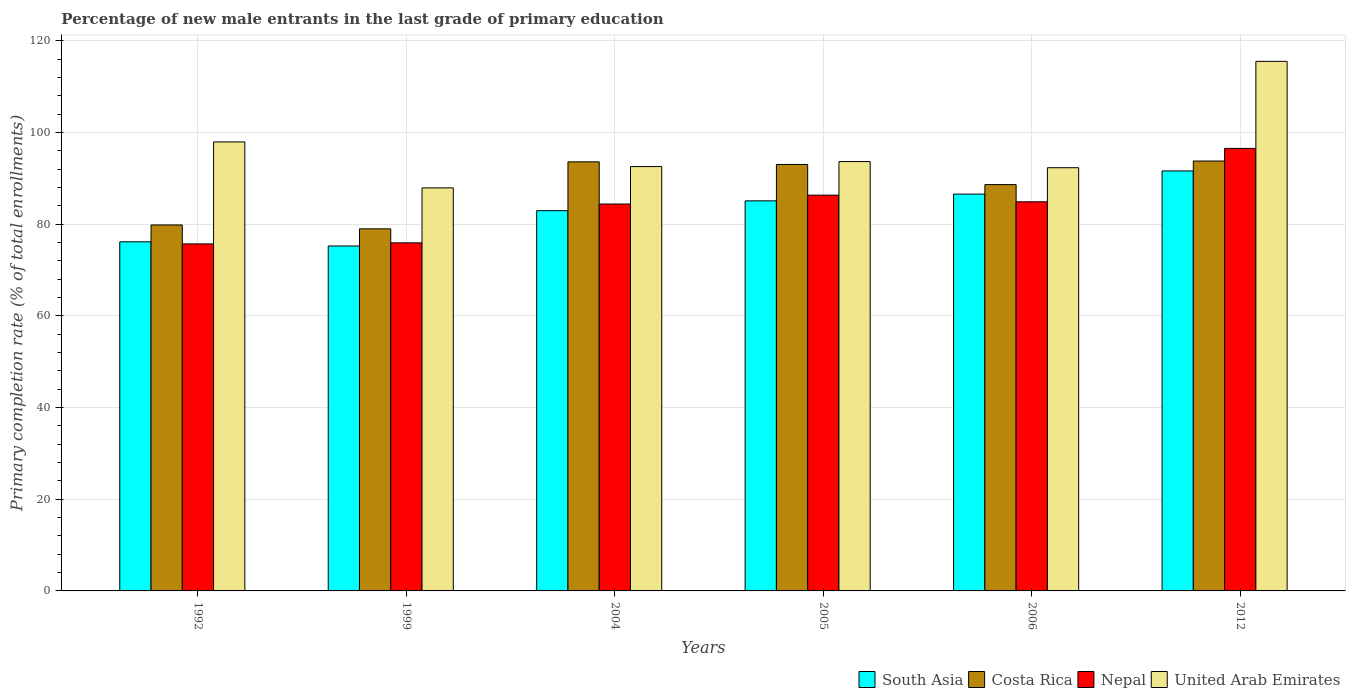How many different coloured bars are there?
Offer a very short reply. 4. How many groups of bars are there?
Provide a succinct answer. 6. What is the label of the 5th group of bars from the left?
Your response must be concise. 2006. What is the percentage of new male entrants in United Arab Emirates in 2004?
Your answer should be very brief. 92.6. Across all years, what is the maximum percentage of new male entrants in South Asia?
Offer a very short reply. 91.64. Across all years, what is the minimum percentage of new male entrants in South Asia?
Your response must be concise. 75.27. In which year was the percentage of new male entrants in South Asia minimum?
Ensure brevity in your answer.  1999. What is the total percentage of new male entrants in Nepal in the graph?
Your response must be concise. 503.93. What is the difference between the percentage of new male entrants in Nepal in 1999 and that in 2004?
Ensure brevity in your answer.  -8.47. What is the difference between the percentage of new male entrants in United Arab Emirates in 2006 and the percentage of new male entrants in South Asia in 1999?
Give a very brief answer. 17.08. What is the average percentage of new male entrants in Costa Rica per year?
Your answer should be very brief. 88. In the year 2004, what is the difference between the percentage of new male entrants in United Arab Emirates and percentage of new male entrants in Costa Rica?
Offer a very short reply. -1.03. In how many years, is the percentage of new male entrants in United Arab Emirates greater than 40 %?
Provide a succinct answer. 6. What is the ratio of the percentage of new male entrants in Costa Rica in 1992 to that in 1999?
Your answer should be very brief. 1.01. Is the percentage of new male entrants in Costa Rica in 1992 less than that in 2006?
Your response must be concise. Yes. What is the difference between the highest and the second highest percentage of new male entrants in Costa Rica?
Offer a very short reply. 0.17. What is the difference between the highest and the lowest percentage of new male entrants in South Asia?
Ensure brevity in your answer.  16.38. Is it the case that in every year, the sum of the percentage of new male entrants in Nepal and percentage of new male entrants in Costa Rica is greater than the sum of percentage of new male entrants in South Asia and percentage of new male entrants in United Arab Emirates?
Make the answer very short. No. What does the 1st bar from the left in 2012 represents?
Ensure brevity in your answer.  South Asia. Is it the case that in every year, the sum of the percentage of new male entrants in United Arab Emirates and percentage of new male entrants in Nepal is greater than the percentage of new male entrants in South Asia?
Give a very brief answer. Yes. How many bars are there?
Your answer should be very brief. 24. Are all the bars in the graph horizontal?
Your response must be concise. No. How many years are there in the graph?
Provide a short and direct response. 6. Does the graph contain grids?
Provide a succinct answer. Yes. How are the legend labels stacked?
Your response must be concise. Horizontal. What is the title of the graph?
Your answer should be compact. Percentage of new male entrants in the last grade of primary education. Does "Greece" appear as one of the legend labels in the graph?
Your answer should be compact. No. What is the label or title of the X-axis?
Provide a succinct answer. Years. What is the label or title of the Y-axis?
Offer a very short reply. Primary completion rate (% of total enrollments). What is the Primary completion rate (% of total enrollments) of South Asia in 1992?
Make the answer very short. 76.18. What is the Primary completion rate (% of total enrollments) of Costa Rica in 1992?
Keep it short and to the point. 79.86. What is the Primary completion rate (% of total enrollments) of Nepal in 1992?
Your answer should be compact. 75.72. What is the Primary completion rate (% of total enrollments) in United Arab Emirates in 1992?
Ensure brevity in your answer.  97.98. What is the Primary completion rate (% of total enrollments) in South Asia in 1999?
Offer a very short reply. 75.27. What is the Primary completion rate (% of total enrollments) of Costa Rica in 1999?
Provide a short and direct response. 79.01. What is the Primary completion rate (% of total enrollments) of Nepal in 1999?
Provide a succinct answer. 75.95. What is the Primary completion rate (% of total enrollments) of United Arab Emirates in 1999?
Your answer should be very brief. 87.95. What is the Primary completion rate (% of total enrollments) of South Asia in 2004?
Your response must be concise. 82.98. What is the Primary completion rate (% of total enrollments) in Costa Rica in 2004?
Provide a succinct answer. 93.63. What is the Primary completion rate (% of total enrollments) of Nepal in 2004?
Provide a succinct answer. 84.42. What is the Primary completion rate (% of total enrollments) in United Arab Emirates in 2004?
Ensure brevity in your answer.  92.6. What is the Primary completion rate (% of total enrollments) in South Asia in 2005?
Keep it short and to the point. 85.12. What is the Primary completion rate (% of total enrollments) in Costa Rica in 2005?
Your answer should be compact. 93.06. What is the Primary completion rate (% of total enrollments) of Nepal in 2005?
Your answer should be compact. 86.36. What is the Primary completion rate (% of total enrollments) in United Arab Emirates in 2005?
Offer a very short reply. 93.69. What is the Primary completion rate (% of total enrollments) of South Asia in 2006?
Offer a very short reply. 86.59. What is the Primary completion rate (% of total enrollments) in Costa Rica in 2006?
Provide a short and direct response. 88.66. What is the Primary completion rate (% of total enrollments) in Nepal in 2006?
Keep it short and to the point. 84.91. What is the Primary completion rate (% of total enrollments) of United Arab Emirates in 2006?
Offer a very short reply. 92.35. What is the Primary completion rate (% of total enrollments) in South Asia in 2012?
Offer a terse response. 91.64. What is the Primary completion rate (% of total enrollments) in Costa Rica in 2012?
Give a very brief answer. 93.8. What is the Primary completion rate (% of total enrollments) in Nepal in 2012?
Provide a short and direct response. 96.56. What is the Primary completion rate (% of total enrollments) of United Arab Emirates in 2012?
Provide a succinct answer. 115.56. Across all years, what is the maximum Primary completion rate (% of total enrollments) in South Asia?
Make the answer very short. 91.64. Across all years, what is the maximum Primary completion rate (% of total enrollments) in Costa Rica?
Offer a terse response. 93.8. Across all years, what is the maximum Primary completion rate (% of total enrollments) of Nepal?
Offer a very short reply. 96.56. Across all years, what is the maximum Primary completion rate (% of total enrollments) in United Arab Emirates?
Ensure brevity in your answer.  115.56. Across all years, what is the minimum Primary completion rate (% of total enrollments) in South Asia?
Offer a very short reply. 75.27. Across all years, what is the minimum Primary completion rate (% of total enrollments) in Costa Rica?
Your answer should be very brief. 79.01. Across all years, what is the minimum Primary completion rate (% of total enrollments) of Nepal?
Your response must be concise. 75.72. Across all years, what is the minimum Primary completion rate (% of total enrollments) of United Arab Emirates?
Offer a very short reply. 87.95. What is the total Primary completion rate (% of total enrollments) in South Asia in the graph?
Offer a terse response. 497.77. What is the total Primary completion rate (% of total enrollments) of Costa Rica in the graph?
Offer a very short reply. 528.02. What is the total Primary completion rate (% of total enrollments) of Nepal in the graph?
Ensure brevity in your answer.  503.93. What is the total Primary completion rate (% of total enrollments) of United Arab Emirates in the graph?
Provide a succinct answer. 580.12. What is the difference between the Primary completion rate (% of total enrollments) in South Asia in 1992 and that in 1999?
Ensure brevity in your answer.  0.91. What is the difference between the Primary completion rate (% of total enrollments) in Costa Rica in 1992 and that in 1999?
Provide a short and direct response. 0.85. What is the difference between the Primary completion rate (% of total enrollments) of Nepal in 1992 and that in 1999?
Keep it short and to the point. -0.23. What is the difference between the Primary completion rate (% of total enrollments) in United Arab Emirates in 1992 and that in 1999?
Provide a succinct answer. 10.03. What is the difference between the Primary completion rate (% of total enrollments) in South Asia in 1992 and that in 2004?
Ensure brevity in your answer.  -6.8. What is the difference between the Primary completion rate (% of total enrollments) of Costa Rica in 1992 and that in 2004?
Keep it short and to the point. -13.77. What is the difference between the Primary completion rate (% of total enrollments) of Nepal in 1992 and that in 2004?
Give a very brief answer. -8.7. What is the difference between the Primary completion rate (% of total enrollments) in United Arab Emirates in 1992 and that in 2004?
Provide a succinct answer. 5.38. What is the difference between the Primary completion rate (% of total enrollments) in South Asia in 1992 and that in 2005?
Your answer should be very brief. -8.94. What is the difference between the Primary completion rate (% of total enrollments) in Costa Rica in 1992 and that in 2005?
Your answer should be very brief. -13.2. What is the difference between the Primary completion rate (% of total enrollments) in Nepal in 1992 and that in 2005?
Provide a short and direct response. -10.64. What is the difference between the Primary completion rate (% of total enrollments) in United Arab Emirates in 1992 and that in 2005?
Ensure brevity in your answer.  4.28. What is the difference between the Primary completion rate (% of total enrollments) of South Asia in 1992 and that in 2006?
Offer a very short reply. -10.41. What is the difference between the Primary completion rate (% of total enrollments) in Costa Rica in 1992 and that in 2006?
Make the answer very short. -8.81. What is the difference between the Primary completion rate (% of total enrollments) in Nepal in 1992 and that in 2006?
Offer a terse response. -9.19. What is the difference between the Primary completion rate (% of total enrollments) in United Arab Emirates in 1992 and that in 2006?
Keep it short and to the point. 5.63. What is the difference between the Primary completion rate (% of total enrollments) in South Asia in 1992 and that in 2012?
Provide a succinct answer. -15.46. What is the difference between the Primary completion rate (% of total enrollments) in Costa Rica in 1992 and that in 2012?
Provide a succinct answer. -13.95. What is the difference between the Primary completion rate (% of total enrollments) of Nepal in 1992 and that in 2012?
Offer a terse response. -20.84. What is the difference between the Primary completion rate (% of total enrollments) in United Arab Emirates in 1992 and that in 2012?
Make the answer very short. -17.58. What is the difference between the Primary completion rate (% of total enrollments) of South Asia in 1999 and that in 2004?
Keep it short and to the point. -7.71. What is the difference between the Primary completion rate (% of total enrollments) of Costa Rica in 1999 and that in 2004?
Offer a terse response. -14.62. What is the difference between the Primary completion rate (% of total enrollments) of Nepal in 1999 and that in 2004?
Your response must be concise. -8.47. What is the difference between the Primary completion rate (% of total enrollments) of United Arab Emirates in 1999 and that in 2004?
Offer a terse response. -4.65. What is the difference between the Primary completion rate (% of total enrollments) in South Asia in 1999 and that in 2005?
Your answer should be compact. -9.85. What is the difference between the Primary completion rate (% of total enrollments) in Costa Rica in 1999 and that in 2005?
Give a very brief answer. -14.05. What is the difference between the Primary completion rate (% of total enrollments) in Nepal in 1999 and that in 2005?
Offer a terse response. -10.41. What is the difference between the Primary completion rate (% of total enrollments) in United Arab Emirates in 1999 and that in 2005?
Give a very brief answer. -5.74. What is the difference between the Primary completion rate (% of total enrollments) in South Asia in 1999 and that in 2006?
Give a very brief answer. -11.32. What is the difference between the Primary completion rate (% of total enrollments) of Costa Rica in 1999 and that in 2006?
Your answer should be compact. -9.65. What is the difference between the Primary completion rate (% of total enrollments) of Nepal in 1999 and that in 2006?
Your response must be concise. -8.96. What is the difference between the Primary completion rate (% of total enrollments) of United Arab Emirates in 1999 and that in 2006?
Your answer should be very brief. -4.4. What is the difference between the Primary completion rate (% of total enrollments) in South Asia in 1999 and that in 2012?
Your response must be concise. -16.38. What is the difference between the Primary completion rate (% of total enrollments) in Costa Rica in 1999 and that in 2012?
Your response must be concise. -14.79. What is the difference between the Primary completion rate (% of total enrollments) in Nepal in 1999 and that in 2012?
Ensure brevity in your answer.  -20.61. What is the difference between the Primary completion rate (% of total enrollments) in United Arab Emirates in 1999 and that in 2012?
Keep it short and to the point. -27.61. What is the difference between the Primary completion rate (% of total enrollments) of South Asia in 2004 and that in 2005?
Ensure brevity in your answer.  -2.14. What is the difference between the Primary completion rate (% of total enrollments) of Costa Rica in 2004 and that in 2005?
Offer a very short reply. 0.57. What is the difference between the Primary completion rate (% of total enrollments) of Nepal in 2004 and that in 2005?
Offer a very short reply. -1.94. What is the difference between the Primary completion rate (% of total enrollments) in United Arab Emirates in 2004 and that in 2005?
Your answer should be compact. -1.1. What is the difference between the Primary completion rate (% of total enrollments) in South Asia in 2004 and that in 2006?
Ensure brevity in your answer.  -3.61. What is the difference between the Primary completion rate (% of total enrollments) in Costa Rica in 2004 and that in 2006?
Provide a short and direct response. 4.97. What is the difference between the Primary completion rate (% of total enrollments) of Nepal in 2004 and that in 2006?
Provide a succinct answer. -0.49. What is the difference between the Primary completion rate (% of total enrollments) of United Arab Emirates in 2004 and that in 2006?
Your answer should be compact. 0.25. What is the difference between the Primary completion rate (% of total enrollments) of South Asia in 2004 and that in 2012?
Provide a succinct answer. -8.67. What is the difference between the Primary completion rate (% of total enrollments) in Costa Rica in 2004 and that in 2012?
Provide a succinct answer. -0.17. What is the difference between the Primary completion rate (% of total enrollments) in Nepal in 2004 and that in 2012?
Provide a succinct answer. -12.14. What is the difference between the Primary completion rate (% of total enrollments) of United Arab Emirates in 2004 and that in 2012?
Your answer should be compact. -22.96. What is the difference between the Primary completion rate (% of total enrollments) of South Asia in 2005 and that in 2006?
Give a very brief answer. -1.47. What is the difference between the Primary completion rate (% of total enrollments) of Costa Rica in 2005 and that in 2006?
Your response must be concise. 4.39. What is the difference between the Primary completion rate (% of total enrollments) in Nepal in 2005 and that in 2006?
Your answer should be very brief. 1.45. What is the difference between the Primary completion rate (% of total enrollments) in United Arab Emirates in 2005 and that in 2006?
Make the answer very short. 1.34. What is the difference between the Primary completion rate (% of total enrollments) in South Asia in 2005 and that in 2012?
Keep it short and to the point. -6.53. What is the difference between the Primary completion rate (% of total enrollments) of Costa Rica in 2005 and that in 2012?
Ensure brevity in your answer.  -0.75. What is the difference between the Primary completion rate (% of total enrollments) in Nepal in 2005 and that in 2012?
Provide a succinct answer. -10.2. What is the difference between the Primary completion rate (% of total enrollments) of United Arab Emirates in 2005 and that in 2012?
Offer a terse response. -21.87. What is the difference between the Primary completion rate (% of total enrollments) in South Asia in 2006 and that in 2012?
Ensure brevity in your answer.  -5.05. What is the difference between the Primary completion rate (% of total enrollments) of Costa Rica in 2006 and that in 2012?
Provide a succinct answer. -5.14. What is the difference between the Primary completion rate (% of total enrollments) in Nepal in 2006 and that in 2012?
Offer a very short reply. -11.65. What is the difference between the Primary completion rate (% of total enrollments) in United Arab Emirates in 2006 and that in 2012?
Your response must be concise. -23.21. What is the difference between the Primary completion rate (% of total enrollments) in South Asia in 1992 and the Primary completion rate (% of total enrollments) in Costa Rica in 1999?
Offer a terse response. -2.83. What is the difference between the Primary completion rate (% of total enrollments) in South Asia in 1992 and the Primary completion rate (% of total enrollments) in Nepal in 1999?
Provide a succinct answer. 0.23. What is the difference between the Primary completion rate (% of total enrollments) in South Asia in 1992 and the Primary completion rate (% of total enrollments) in United Arab Emirates in 1999?
Give a very brief answer. -11.77. What is the difference between the Primary completion rate (% of total enrollments) in Costa Rica in 1992 and the Primary completion rate (% of total enrollments) in Nepal in 1999?
Offer a terse response. 3.91. What is the difference between the Primary completion rate (% of total enrollments) of Costa Rica in 1992 and the Primary completion rate (% of total enrollments) of United Arab Emirates in 1999?
Keep it short and to the point. -8.09. What is the difference between the Primary completion rate (% of total enrollments) in Nepal in 1992 and the Primary completion rate (% of total enrollments) in United Arab Emirates in 1999?
Your response must be concise. -12.23. What is the difference between the Primary completion rate (% of total enrollments) of South Asia in 1992 and the Primary completion rate (% of total enrollments) of Costa Rica in 2004?
Provide a short and direct response. -17.45. What is the difference between the Primary completion rate (% of total enrollments) of South Asia in 1992 and the Primary completion rate (% of total enrollments) of Nepal in 2004?
Provide a short and direct response. -8.24. What is the difference between the Primary completion rate (% of total enrollments) in South Asia in 1992 and the Primary completion rate (% of total enrollments) in United Arab Emirates in 2004?
Offer a very short reply. -16.42. What is the difference between the Primary completion rate (% of total enrollments) of Costa Rica in 1992 and the Primary completion rate (% of total enrollments) of Nepal in 2004?
Provide a succinct answer. -4.57. What is the difference between the Primary completion rate (% of total enrollments) of Costa Rica in 1992 and the Primary completion rate (% of total enrollments) of United Arab Emirates in 2004?
Provide a short and direct response. -12.74. What is the difference between the Primary completion rate (% of total enrollments) of Nepal in 1992 and the Primary completion rate (% of total enrollments) of United Arab Emirates in 2004?
Offer a terse response. -16.88. What is the difference between the Primary completion rate (% of total enrollments) of South Asia in 1992 and the Primary completion rate (% of total enrollments) of Costa Rica in 2005?
Ensure brevity in your answer.  -16.88. What is the difference between the Primary completion rate (% of total enrollments) in South Asia in 1992 and the Primary completion rate (% of total enrollments) in Nepal in 2005?
Give a very brief answer. -10.18. What is the difference between the Primary completion rate (% of total enrollments) of South Asia in 1992 and the Primary completion rate (% of total enrollments) of United Arab Emirates in 2005?
Your answer should be very brief. -17.51. What is the difference between the Primary completion rate (% of total enrollments) of Costa Rica in 1992 and the Primary completion rate (% of total enrollments) of Nepal in 2005?
Your response must be concise. -6.51. What is the difference between the Primary completion rate (% of total enrollments) of Costa Rica in 1992 and the Primary completion rate (% of total enrollments) of United Arab Emirates in 2005?
Ensure brevity in your answer.  -13.83. What is the difference between the Primary completion rate (% of total enrollments) of Nepal in 1992 and the Primary completion rate (% of total enrollments) of United Arab Emirates in 2005?
Give a very brief answer. -17.97. What is the difference between the Primary completion rate (% of total enrollments) in South Asia in 1992 and the Primary completion rate (% of total enrollments) in Costa Rica in 2006?
Offer a terse response. -12.48. What is the difference between the Primary completion rate (% of total enrollments) of South Asia in 1992 and the Primary completion rate (% of total enrollments) of Nepal in 2006?
Your answer should be very brief. -8.73. What is the difference between the Primary completion rate (% of total enrollments) of South Asia in 1992 and the Primary completion rate (% of total enrollments) of United Arab Emirates in 2006?
Ensure brevity in your answer.  -16.17. What is the difference between the Primary completion rate (% of total enrollments) in Costa Rica in 1992 and the Primary completion rate (% of total enrollments) in Nepal in 2006?
Make the answer very short. -5.06. What is the difference between the Primary completion rate (% of total enrollments) in Costa Rica in 1992 and the Primary completion rate (% of total enrollments) in United Arab Emirates in 2006?
Ensure brevity in your answer.  -12.49. What is the difference between the Primary completion rate (% of total enrollments) of Nepal in 1992 and the Primary completion rate (% of total enrollments) of United Arab Emirates in 2006?
Keep it short and to the point. -16.63. What is the difference between the Primary completion rate (% of total enrollments) in South Asia in 1992 and the Primary completion rate (% of total enrollments) in Costa Rica in 2012?
Provide a succinct answer. -17.62. What is the difference between the Primary completion rate (% of total enrollments) in South Asia in 1992 and the Primary completion rate (% of total enrollments) in Nepal in 2012?
Your response must be concise. -20.38. What is the difference between the Primary completion rate (% of total enrollments) in South Asia in 1992 and the Primary completion rate (% of total enrollments) in United Arab Emirates in 2012?
Offer a very short reply. -39.38. What is the difference between the Primary completion rate (% of total enrollments) in Costa Rica in 1992 and the Primary completion rate (% of total enrollments) in Nepal in 2012?
Offer a very short reply. -16.71. What is the difference between the Primary completion rate (% of total enrollments) in Costa Rica in 1992 and the Primary completion rate (% of total enrollments) in United Arab Emirates in 2012?
Your answer should be very brief. -35.7. What is the difference between the Primary completion rate (% of total enrollments) of Nepal in 1992 and the Primary completion rate (% of total enrollments) of United Arab Emirates in 2012?
Provide a short and direct response. -39.84. What is the difference between the Primary completion rate (% of total enrollments) in South Asia in 1999 and the Primary completion rate (% of total enrollments) in Costa Rica in 2004?
Your answer should be very brief. -18.36. What is the difference between the Primary completion rate (% of total enrollments) in South Asia in 1999 and the Primary completion rate (% of total enrollments) in Nepal in 2004?
Your answer should be compact. -9.16. What is the difference between the Primary completion rate (% of total enrollments) of South Asia in 1999 and the Primary completion rate (% of total enrollments) of United Arab Emirates in 2004?
Your answer should be compact. -17.33. What is the difference between the Primary completion rate (% of total enrollments) of Costa Rica in 1999 and the Primary completion rate (% of total enrollments) of Nepal in 2004?
Your answer should be compact. -5.41. What is the difference between the Primary completion rate (% of total enrollments) in Costa Rica in 1999 and the Primary completion rate (% of total enrollments) in United Arab Emirates in 2004?
Provide a short and direct response. -13.59. What is the difference between the Primary completion rate (% of total enrollments) in Nepal in 1999 and the Primary completion rate (% of total enrollments) in United Arab Emirates in 2004?
Offer a terse response. -16.65. What is the difference between the Primary completion rate (% of total enrollments) in South Asia in 1999 and the Primary completion rate (% of total enrollments) in Costa Rica in 2005?
Your response must be concise. -17.79. What is the difference between the Primary completion rate (% of total enrollments) of South Asia in 1999 and the Primary completion rate (% of total enrollments) of Nepal in 2005?
Provide a short and direct response. -11.1. What is the difference between the Primary completion rate (% of total enrollments) in South Asia in 1999 and the Primary completion rate (% of total enrollments) in United Arab Emirates in 2005?
Make the answer very short. -18.43. What is the difference between the Primary completion rate (% of total enrollments) in Costa Rica in 1999 and the Primary completion rate (% of total enrollments) in Nepal in 2005?
Ensure brevity in your answer.  -7.35. What is the difference between the Primary completion rate (% of total enrollments) of Costa Rica in 1999 and the Primary completion rate (% of total enrollments) of United Arab Emirates in 2005?
Offer a terse response. -14.68. What is the difference between the Primary completion rate (% of total enrollments) of Nepal in 1999 and the Primary completion rate (% of total enrollments) of United Arab Emirates in 2005?
Ensure brevity in your answer.  -17.74. What is the difference between the Primary completion rate (% of total enrollments) in South Asia in 1999 and the Primary completion rate (% of total enrollments) in Costa Rica in 2006?
Keep it short and to the point. -13.4. What is the difference between the Primary completion rate (% of total enrollments) of South Asia in 1999 and the Primary completion rate (% of total enrollments) of Nepal in 2006?
Give a very brief answer. -9.65. What is the difference between the Primary completion rate (% of total enrollments) in South Asia in 1999 and the Primary completion rate (% of total enrollments) in United Arab Emirates in 2006?
Your answer should be compact. -17.08. What is the difference between the Primary completion rate (% of total enrollments) of Costa Rica in 1999 and the Primary completion rate (% of total enrollments) of Nepal in 2006?
Keep it short and to the point. -5.9. What is the difference between the Primary completion rate (% of total enrollments) of Costa Rica in 1999 and the Primary completion rate (% of total enrollments) of United Arab Emirates in 2006?
Your answer should be compact. -13.34. What is the difference between the Primary completion rate (% of total enrollments) in Nepal in 1999 and the Primary completion rate (% of total enrollments) in United Arab Emirates in 2006?
Your answer should be compact. -16.4. What is the difference between the Primary completion rate (% of total enrollments) of South Asia in 1999 and the Primary completion rate (% of total enrollments) of Costa Rica in 2012?
Give a very brief answer. -18.54. What is the difference between the Primary completion rate (% of total enrollments) in South Asia in 1999 and the Primary completion rate (% of total enrollments) in Nepal in 2012?
Offer a terse response. -21.3. What is the difference between the Primary completion rate (% of total enrollments) of South Asia in 1999 and the Primary completion rate (% of total enrollments) of United Arab Emirates in 2012?
Make the answer very short. -40.29. What is the difference between the Primary completion rate (% of total enrollments) of Costa Rica in 1999 and the Primary completion rate (% of total enrollments) of Nepal in 2012?
Offer a terse response. -17.55. What is the difference between the Primary completion rate (% of total enrollments) in Costa Rica in 1999 and the Primary completion rate (% of total enrollments) in United Arab Emirates in 2012?
Make the answer very short. -36.55. What is the difference between the Primary completion rate (% of total enrollments) in Nepal in 1999 and the Primary completion rate (% of total enrollments) in United Arab Emirates in 2012?
Provide a succinct answer. -39.61. What is the difference between the Primary completion rate (% of total enrollments) of South Asia in 2004 and the Primary completion rate (% of total enrollments) of Costa Rica in 2005?
Provide a short and direct response. -10.08. What is the difference between the Primary completion rate (% of total enrollments) in South Asia in 2004 and the Primary completion rate (% of total enrollments) in Nepal in 2005?
Keep it short and to the point. -3.39. What is the difference between the Primary completion rate (% of total enrollments) of South Asia in 2004 and the Primary completion rate (% of total enrollments) of United Arab Emirates in 2005?
Your answer should be very brief. -10.72. What is the difference between the Primary completion rate (% of total enrollments) in Costa Rica in 2004 and the Primary completion rate (% of total enrollments) in Nepal in 2005?
Ensure brevity in your answer.  7.27. What is the difference between the Primary completion rate (% of total enrollments) of Costa Rica in 2004 and the Primary completion rate (% of total enrollments) of United Arab Emirates in 2005?
Ensure brevity in your answer.  -0.06. What is the difference between the Primary completion rate (% of total enrollments) in Nepal in 2004 and the Primary completion rate (% of total enrollments) in United Arab Emirates in 2005?
Provide a succinct answer. -9.27. What is the difference between the Primary completion rate (% of total enrollments) in South Asia in 2004 and the Primary completion rate (% of total enrollments) in Costa Rica in 2006?
Provide a succinct answer. -5.69. What is the difference between the Primary completion rate (% of total enrollments) of South Asia in 2004 and the Primary completion rate (% of total enrollments) of Nepal in 2006?
Your answer should be compact. -1.94. What is the difference between the Primary completion rate (% of total enrollments) of South Asia in 2004 and the Primary completion rate (% of total enrollments) of United Arab Emirates in 2006?
Make the answer very short. -9.37. What is the difference between the Primary completion rate (% of total enrollments) in Costa Rica in 2004 and the Primary completion rate (% of total enrollments) in Nepal in 2006?
Ensure brevity in your answer.  8.72. What is the difference between the Primary completion rate (% of total enrollments) in Costa Rica in 2004 and the Primary completion rate (% of total enrollments) in United Arab Emirates in 2006?
Keep it short and to the point. 1.28. What is the difference between the Primary completion rate (% of total enrollments) of Nepal in 2004 and the Primary completion rate (% of total enrollments) of United Arab Emirates in 2006?
Your answer should be very brief. -7.92. What is the difference between the Primary completion rate (% of total enrollments) in South Asia in 2004 and the Primary completion rate (% of total enrollments) in Costa Rica in 2012?
Your response must be concise. -10.83. What is the difference between the Primary completion rate (% of total enrollments) in South Asia in 2004 and the Primary completion rate (% of total enrollments) in Nepal in 2012?
Your answer should be compact. -13.59. What is the difference between the Primary completion rate (% of total enrollments) in South Asia in 2004 and the Primary completion rate (% of total enrollments) in United Arab Emirates in 2012?
Keep it short and to the point. -32.58. What is the difference between the Primary completion rate (% of total enrollments) of Costa Rica in 2004 and the Primary completion rate (% of total enrollments) of Nepal in 2012?
Give a very brief answer. -2.93. What is the difference between the Primary completion rate (% of total enrollments) of Costa Rica in 2004 and the Primary completion rate (% of total enrollments) of United Arab Emirates in 2012?
Your answer should be very brief. -21.93. What is the difference between the Primary completion rate (% of total enrollments) of Nepal in 2004 and the Primary completion rate (% of total enrollments) of United Arab Emirates in 2012?
Give a very brief answer. -31.13. What is the difference between the Primary completion rate (% of total enrollments) of South Asia in 2005 and the Primary completion rate (% of total enrollments) of Costa Rica in 2006?
Your response must be concise. -3.55. What is the difference between the Primary completion rate (% of total enrollments) of South Asia in 2005 and the Primary completion rate (% of total enrollments) of Nepal in 2006?
Ensure brevity in your answer.  0.2. What is the difference between the Primary completion rate (% of total enrollments) of South Asia in 2005 and the Primary completion rate (% of total enrollments) of United Arab Emirates in 2006?
Keep it short and to the point. -7.23. What is the difference between the Primary completion rate (% of total enrollments) of Costa Rica in 2005 and the Primary completion rate (% of total enrollments) of Nepal in 2006?
Provide a short and direct response. 8.14. What is the difference between the Primary completion rate (% of total enrollments) of Costa Rica in 2005 and the Primary completion rate (% of total enrollments) of United Arab Emirates in 2006?
Keep it short and to the point. 0.71. What is the difference between the Primary completion rate (% of total enrollments) of Nepal in 2005 and the Primary completion rate (% of total enrollments) of United Arab Emirates in 2006?
Keep it short and to the point. -5.98. What is the difference between the Primary completion rate (% of total enrollments) in South Asia in 2005 and the Primary completion rate (% of total enrollments) in Costa Rica in 2012?
Provide a succinct answer. -8.69. What is the difference between the Primary completion rate (% of total enrollments) of South Asia in 2005 and the Primary completion rate (% of total enrollments) of Nepal in 2012?
Ensure brevity in your answer.  -11.45. What is the difference between the Primary completion rate (% of total enrollments) in South Asia in 2005 and the Primary completion rate (% of total enrollments) in United Arab Emirates in 2012?
Offer a terse response. -30.44. What is the difference between the Primary completion rate (% of total enrollments) in Costa Rica in 2005 and the Primary completion rate (% of total enrollments) in Nepal in 2012?
Offer a terse response. -3.51. What is the difference between the Primary completion rate (% of total enrollments) of Costa Rica in 2005 and the Primary completion rate (% of total enrollments) of United Arab Emirates in 2012?
Your answer should be very brief. -22.5. What is the difference between the Primary completion rate (% of total enrollments) in Nepal in 2005 and the Primary completion rate (% of total enrollments) in United Arab Emirates in 2012?
Give a very brief answer. -29.19. What is the difference between the Primary completion rate (% of total enrollments) in South Asia in 2006 and the Primary completion rate (% of total enrollments) in Costa Rica in 2012?
Give a very brief answer. -7.21. What is the difference between the Primary completion rate (% of total enrollments) in South Asia in 2006 and the Primary completion rate (% of total enrollments) in Nepal in 2012?
Offer a terse response. -9.97. What is the difference between the Primary completion rate (% of total enrollments) of South Asia in 2006 and the Primary completion rate (% of total enrollments) of United Arab Emirates in 2012?
Make the answer very short. -28.97. What is the difference between the Primary completion rate (% of total enrollments) of Costa Rica in 2006 and the Primary completion rate (% of total enrollments) of Nepal in 2012?
Offer a very short reply. -7.9. What is the difference between the Primary completion rate (% of total enrollments) in Costa Rica in 2006 and the Primary completion rate (% of total enrollments) in United Arab Emirates in 2012?
Your answer should be very brief. -26.89. What is the difference between the Primary completion rate (% of total enrollments) in Nepal in 2006 and the Primary completion rate (% of total enrollments) in United Arab Emirates in 2012?
Offer a very short reply. -30.64. What is the average Primary completion rate (% of total enrollments) of South Asia per year?
Ensure brevity in your answer.  82.96. What is the average Primary completion rate (% of total enrollments) in Costa Rica per year?
Your response must be concise. 88. What is the average Primary completion rate (% of total enrollments) of Nepal per year?
Provide a succinct answer. 83.99. What is the average Primary completion rate (% of total enrollments) of United Arab Emirates per year?
Your answer should be very brief. 96.69. In the year 1992, what is the difference between the Primary completion rate (% of total enrollments) in South Asia and Primary completion rate (% of total enrollments) in Costa Rica?
Your answer should be compact. -3.68. In the year 1992, what is the difference between the Primary completion rate (% of total enrollments) of South Asia and Primary completion rate (% of total enrollments) of Nepal?
Offer a terse response. 0.46. In the year 1992, what is the difference between the Primary completion rate (% of total enrollments) of South Asia and Primary completion rate (% of total enrollments) of United Arab Emirates?
Keep it short and to the point. -21.8. In the year 1992, what is the difference between the Primary completion rate (% of total enrollments) of Costa Rica and Primary completion rate (% of total enrollments) of Nepal?
Offer a terse response. 4.14. In the year 1992, what is the difference between the Primary completion rate (% of total enrollments) of Costa Rica and Primary completion rate (% of total enrollments) of United Arab Emirates?
Your answer should be very brief. -18.12. In the year 1992, what is the difference between the Primary completion rate (% of total enrollments) of Nepal and Primary completion rate (% of total enrollments) of United Arab Emirates?
Your answer should be very brief. -22.26. In the year 1999, what is the difference between the Primary completion rate (% of total enrollments) of South Asia and Primary completion rate (% of total enrollments) of Costa Rica?
Your answer should be compact. -3.74. In the year 1999, what is the difference between the Primary completion rate (% of total enrollments) in South Asia and Primary completion rate (% of total enrollments) in Nepal?
Give a very brief answer. -0.68. In the year 1999, what is the difference between the Primary completion rate (% of total enrollments) of South Asia and Primary completion rate (% of total enrollments) of United Arab Emirates?
Offer a terse response. -12.68. In the year 1999, what is the difference between the Primary completion rate (% of total enrollments) of Costa Rica and Primary completion rate (% of total enrollments) of Nepal?
Offer a very short reply. 3.06. In the year 1999, what is the difference between the Primary completion rate (% of total enrollments) of Costa Rica and Primary completion rate (% of total enrollments) of United Arab Emirates?
Provide a short and direct response. -8.94. In the year 1999, what is the difference between the Primary completion rate (% of total enrollments) in Nepal and Primary completion rate (% of total enrollments) in United Arab Emirates?
Make the answer very short. -12. In the year 2004, what is the difference between the Primary completion rate (% of total enrollments) of South Asia and Primary completion rate (% of total enrollments) of Costa Rica?
Provide a succinct answer. -10.66. In the year 2004, what is the difference between the Primary completion rate (% of total enrollments) of South Asia and Primary completion rate (% of total enrollments) of Nepal?
Offer a terse response. -1.45. In the year 2004, what is the difference between the Primary completion rate (% of total enrollments) of South Asia and Primary completion rate (% of total enrollments) of United Arab Emirates?
Offer a very short reply. -9.62. In the year 2004, what is the difference between the Primary completion rate (% of total enrollments) of Costa Rica and Primary completion rate (% of total enrollments) of Nepal?
Make the answer very short. 9.21. In the year 2004, what is the difference between the Primary completion rate (% of total enrollments) in Costa Rica and Primary completion rate (% of total enrollments) in United Arab Emirates?
Keep it short and to the point. 1.03. In the year 2004, what is the difference between the Primary completion rate (% of total enrollments) in Nepal and Primary completion rate (% of total enrollments) in United Arab Emirates?
Ensure brevity in your answer.  -8.17. In the year 2005, what is the difference between the Primary completion rate (% of total enrollments) in South Asia and Primary completion rate (% of total enrollments) in Costa Rica?
Keep it short and to the point. -7.94. In the year 2005, what is the difference between the Primary completion rate (% of total enrollments) of South Asia and Primary completion rate (% of total enrollments) of Nepal?
Offer a terse response. -1.25. In the year 2005, what is the difference between the Primary completion rate (% of total enrollments) of South Asia and Primary completion rate (% of total enrollments) of United Arab Emirates?
Provide a succinct answer. -8.58. In the year 2005, what is the difference between the Primary completion rate (% of total enrollments) of Costa Rica and Primary completion rate (% of total enrollments) of Nepal?
Offer a terse response. 6.69. In the year 2005, what is the difference between the Primary completion rate (% of total enrollments) in Costa Rica and Primary completion rate (% of total enrollments) in United Arab Emirates?
Your answer should be compact. -0.63. In the year 2005, what is the difference between the Primary completion rate (% of total enrollments) of Nepal and Primary completion rate (% of total enrollments) of United Arab Emirates?
Your answer should be compact. -7.33. In the year 2006, what is the difference between the Primary completion rate (% of total enrollments) in South Asia and Primary completion rate (% of total enrollments) in Costa Rica?
Keep it short and to the point. -2.07. In the year 2006, what is the difference between the Primary completion rate (% of total enrollments) in South Asia and Primary completion rate (% of total enrollments) in Nepal?
Keep it short and to the point. 1.68. In the year 2006, what is the difference between the Primary completion rate (% of total enrollments) of South Asia and Primary completion rate (% of total enrollments) of United Arab Emirates?
Give a very brief answer. -5.76. In the year 2006, what is the difference between the Primary completion rate (% of total enrollments) in Costa Rica and Primary completion rate (% of total enrollments) in Nepal?
Your response must be concise. 3.75. In the year 2006, what is the difference between the Primary completion rate (% of total enrollments) of Costa Rica and Primary completion rate (% of total enrollments) of United Arab Emirates?
Make the answer very short. -3.69. In the year 2006, what is the difference between the Primary completion rate (% of total enrollments) of Nepal and Primary completion rate (% of total enrollments) of United Arab Emirates?
Your answer should be very brief. -7.43. In the year 2012, what is the difference between the Primary completion rate (% of total enrollments) of South Asia and Primary completion rate (% of total enrollments) of Costa Rica?
Give a very brief answer. -2.16. In the year 2012, what is the difference between the Primary completion rate (% of total enrollments) of South Asia and Primary completion rate (% of total enrollments) of Nepal?
Make the answer very short. -4.92. In the year 2012, what is the difference between the Primary completion rate (% of total enrollments) in South Asia and Primary completion rate (% of total enrollments) in United Arab Emirates?
Ensure brevity in your answer.  -23.91. In the year 2012, what is the difference between the Primary completion rate (% of total enrollments) in Costa Rica and Primary completion rate (% of total enrollments) in Nepal?
Provide a succinct answer. -2.76. In the year 2012, what is the difference between the Primary completion rate (% of total enrollments) of Costa Rica and Primary completion rate (% of total enrollments) of United Arab Emirates?
Keep it short and to the point. -21.75. In the year 2012, what is the difference between the Primary completion rate (% of total enrollments) of Nepal and Primary completion rate (% of total enrollments) of United Arab Emirates?
Make the answer very short. -18.99. What is the ratio of the Primary completion rate (% of total enrollments) in South Asia in 1992 to that in 1999?
Offer a terse response. 1.01. What is the ratio of the Primary completion rate (% of total enrollments) of Costa Rica in 1992 to that in 1999?
Offer a very short reply. 1.01. What is the ratio of the Primary completion rate (% of total enrollments) in Nepal in 1992 to that in 1999?
Your answer should be very brief. 1. What is the ratio of the Primary completion rate (% of total enrollments) in United Arab Emirates in 1992 to that in 1999?
Offer a very short reply. 1.11. What is the ratio of the Primary completion rate (% of total enrollments) of South Asia in 1992 to that in 2004?
Provide a short and direct response. 0.92. What is the ratio of the Primary completion rate (% of total enrollments) in Costa Rica in 1992 to that in 2004?
Offer a very short reply. 0.85. What is the ratio of the Primary completion rate (% of total enrollments) in Nepal in 1992 to that in 2004?
Keep it short and to the point. 0.9. What is the ratio of the Primary completion rate (% of total enrollments) of United Arab Emirates in 1992 to that in 2004?
Your answer should be compact. 1.06. What is the ratio of the Primary completion rate (% of total enrollments) in South Asia in 1992 to that in 2005?
Make the answer very short. 0.9. What is the ratio of the Primary completion rate (% of total enrollments) in Costa Rica in 1992 to that in 2005?
Make the answer very short. 0.86. What is the ratio of the Primary completion rate (% of total enrollments) of Nepal in 1992 to that in 2005?
Offer a terse response. 0.88. What is the ratio of the Primary completion rate (% of total enrollments) in United Arab Emirates in 1992 to that in 2005?
Your answer should be very brief. 1.05. What is the ratio of the Primary completion rate (% of total enrollments) of South Asia in 1992 to that in 2006?
Your answer should be compact. 0.88. What is the ratio of the Primary completion rate (% of total enrollments) of Costa Rica in 1992 to that in 2006?
Your answer should be compact. 0.9. What is the ratio of the Primary completion rate (% of total enrollments) of Nepal in 1992 to that in 2006?
Offer a very short reply. 0.89. What is the ratio of the Primary completion rate (% of total enrollments) of United Arab Emirates in 1992 to that in 2006?
Ensure brevity in your answer.  1.06. What is the ratio of the Primary completion rate (% of total enrollments) in South Asia in 1992 to that in 2012?
Your answer should be very brief. 0.83. What is the ratio of the Primary completion rate (% of total enrollments) of Costa Rica in 1992 to that in 2012?
Give a very brief answer. 0.85. What is the ratio of the Primary completion rate (% of total enrollments) in Nepal in 1992 to that in 2012?
Offer a terse response. 0.78. What is the ratio of the Primary completion rate (% of total enrollments) in United Arab Emirates in 1992 to that in 2012?
Offer a very short reply. 0.85. What is the ratio of the Primary completion rate (% of total enrollments) of South Asia in 1999 to that in 2004?
Offer a terse response. 0.91. What is the ratio of the Primary completion rate (% of total enrollments) of Costa Rica in 1999 to that in 2004?
Your answer should be compact. 0.84. What is the ratio of the Primary completion rate (% of total enrollments) in Nepal in 1999 to that in 2004?
Your response must be concise. 0.9. What is the ratio of the Primary completion rate (% of total enrollments) of United Arab Emirates in 1999 to that in 2004?
Offer a terse response. 0.95. What is the ratio of the Primary completion rate (% of total enrollments) of South Asia in 1999 to that in 2005?
Provide a succinct answer. 0.88. What is the ratio of the Primary completion rate (% of total enrollments) of Costa Rica in 1999 to that in 2005?
Ensure brevity in your answer.  0.85. What is the ratio of the Primary completion rate (% of total enrollments) in Nepal in 1999 to that in 2005?
Keep it short and to the point. 0.88. What is the ratio of the Primary completion rate (% of total enrollments) in United Arab Emirates in 1999 to that in 2005?
Provide a succinct answer. 0.94. What is the ratio of the Primary completion rate (% of total enrollments) of South Asia in 1999 to that in 2006?
Your answer should be compact. 0.87. What is the ratio of the Primary completion rate (% of total enrollments) in Costa Rica in 1999 to that in 2006?
Ensure brevity in your answer.  0.89. What is the ratio of the Primary completion rate (% of total enrollments) in Nepal in 1999 to that in 2006?
Ensure brevity in your answer.  0.89. What is the ratio of the Primary completion rate (% of total enrollments) of United Arab Emirates in 1999 to that in 2006?
Offer a terse response. 0.95. What is the ratio of the Primary completion rate (% of total enrollments) of South Asia in 1999 to that in 2012?
Give a very brief answer. 0.82. What is the ratio of the Primary completion rate (% of total enrollments) in Costa Rica in 1999 to that in 2012?
Provide a succinct answer. 0.84. What is the ratio of the Primary completion rate (% of total enrollments) of Nepal in 1999 to that in 2012?
Offer a terse response. 0.79. What is the ratio of the Primary completion rate (% of total enrollments) of United Arab Emirates in 1999 to that in 2012?
Make the answer very short. 0.76. What is the ratio of the Primary completion rate (% of total enrollments) of South Asia in 2004 to that in 2005?
Your response must be concise. 0.97. What is the ratio of the Primary completion rate (% of total enrollments) of Nepal in 2004 to that in 2005?
Your response must be concise. 0.98. What is the ratio of the Primary completion rate (% of total enrollments) in United Arab Emirates in 2004 to that in 2005?
Ensure brevity in your answer.  0.99. What is the ratio of the Primary completion rate (% of total enrollments) of South Asia in 2004 to that in 2006?
Offer a terse response. 0.96. What is the ratio of the Primary completion rate (% of total enrollments) of Costa Rica in 2004 to that in 2006?
Offer a terse response. 1.06. What is the ratio of the Primary completion rate (% of total enrollments) of Nepal in 2004 to that in 2006?
Provide a short and direct response. 0.99. What is the ratio of the Primary completion rate (% of total enrollments) in South Asia in 2004 to that in 2012?
Provide a short and direct response. 0.91. What is the ratio of the Primary completion rate (% of total enrollments) in Costa Rica in 2004 to that in 2012?
Provide a succinct answer. 1. What is the ratio of the Primary completion rate (% of total enrollments) in Nepal in 2004 to that in 2012?
Your answer should be compact. 0.87. What is the ratio of the Primary completion rate (% of total enrollments) in United Arab Emirates in 2004 to that in 2012?
Make the answer very short. 0.8. What is the ratio of the Primary completion rate (% of total enrollments) in Costa Rica in 2005 to that in 2006?
Provide a short and direct response. 1.05. What is the ratio of the Primary completion rate (% of total enrollments) of Nepal in 2005 to that in 2006?
Make the answer very short. 1.02. What is the ratio of the Primary completion rate (% of total enrollments) of United Arab Emirates in 2005 to that in 2006?
Your answer should be very brief. 1.01. What is the ratio of the Primary completion rate (% of total enrollments) in South Asia in 2005 to that in 2012?
Keep it short and to the point. 0.93. What is the ratio of the Primary completion rate (% of total enrollments) in Nepal in 2005 to that in 2012?
Offer a terse response. 0.89. What is the ratio of the Primary completion rate (% of total enrollments) of United Arab Emirates in 2005 to that in 2012?
Offer a very short reply. 0.81. What is the ratio of the Primary completion rate (% of total enrollments) in South Asia in 2006 to that in 2012?
Ensure brevity in your answer.  0.94. What is the ratio of the Primary completion rate (% of total enrollments) in Costa Rica in 2006 to that in 2012?
Provide a succinct answer. 0.95. What is the ratio of the Primary completion rate (% of total enrollments) in Nepal in 2006 to that in 2012?
Ensure brevity in your answer.  0.88. What is the ratio of the Primary completion rate (% of total enrollments) of United Arab Emirates in 2006 to that in 2012?
Provide a succinct answer. 0.8. What is the difference between the highest and the second highest Primary completion rate (% of total enrollments) in South Asia?
Your answer should be very brief. 5.05. What is the difference between the highest and the second highest Primary completion rate (% of total enrollments) of Costa Rica?
Offer a very short reply. 0.17. What is the difference between the highest and the second highest Primary completion rate (% of total enrollments) in Nepal?
Provide a short and direct response. 10.2. What is the difference between the highest and the second highest Primary completion rate (% of total enrollments) of United Arab Emirates?
Give a very brief answer. 17.58. What is the difference between the highest and the lowest Primary completion rate (% of total enrollments) of South Asia?
Ensure brevity in your answer.  16.38. What is the difference between the highest and the lowest Primary completion rate (% of total enrollments) of Costa Rica?
Offer a very short reply. 14.79. What is the difference between the highest and the lowest Primary completion rate (% of total enrollments) of Nepal?
Keep it short and to the point. 20.84. What is the difference between the highest and the lowest Primary completion rate (% of total enrollments) in United Arab Emirates?
Your response must be concise. 27.61. 